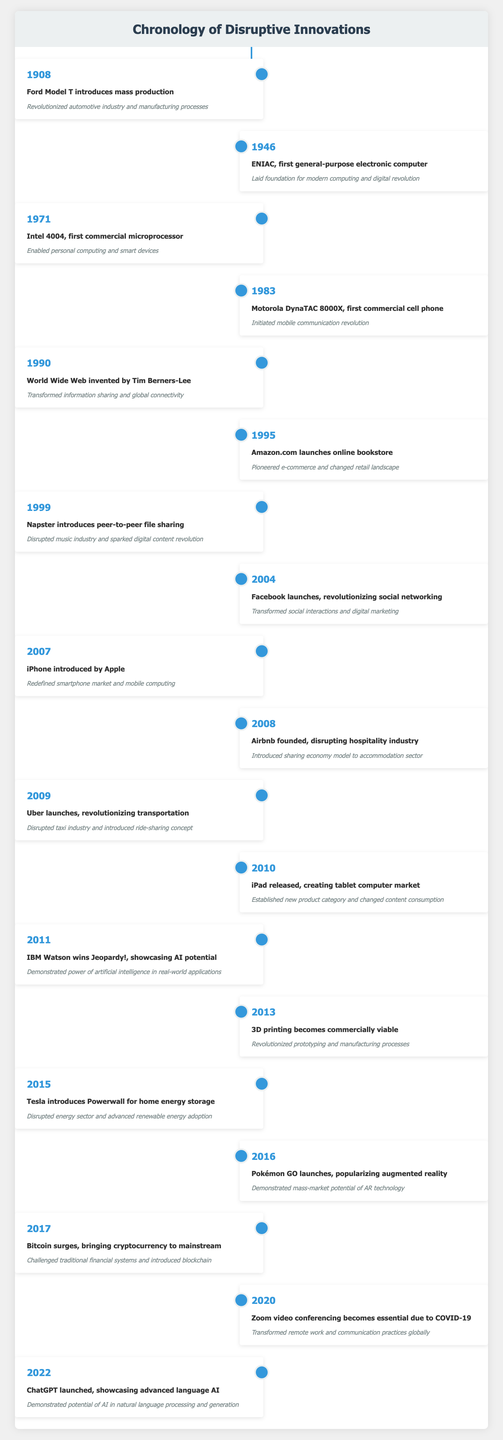What year was the first commercial cell phone introduced? The table states that the Motorola DynaTAC 8000X, which is the first commercial cell phone, was introduced in 1983.
Answer: 1983 What impact did the iPhone introduced by Apple have on the market? According to the table, the impact of the iPhone was that it redefined the smartphone market and mobile computing.
Answer: Redefined smartphone market and mobile computing How many years passed between the introduction of the Ford Model T and the ENIAC? The Ford Model T was introduced in 1908 and the ENIAC in 1946. The difference between 1946 and 1908 is 38 years.
Answer: 38 Was the World Wide Web invented before or after the introduction of Amazon.com? The table shows that the World Wide Web was invented in 1990 and Amazon.com launched in 1995. Thus, the Web was invented before Amazon.com.
Answer: Before Which innovation is associated with the year 2017? The table lists Bitcoin surging in 2017, bringing cryptocurrency to the mainstream.
Answer: Bitcoin How many innovations were introduced before the year 2000? Counting the events listed in the table, the innovations before 2000 are Ford Model T (1908), ENIAC (1946), Intel 4004 (1971), Motorola DynaTAC 8000X (1983), World Wide Web (1990), Amazon.com (1995), and Napster (1999), totaling 7 innovations.
Answer: 7 Which two innovations led to major shifts in communication technology? The table highlights that the Motorola DynaTAC 8000X initiated a mobile communication revolution and the World Wide Web transformed information sharing.
Answer: Motorola DynaTAC 8000X and World Wide Web What is the earliest innovation listed in the table, and what was its impact? The earliest innovation in the timeline is the Ford Model T introduced in 1908, which revolutionized the automotive industry and manufacturing processes.
Answer: Ford Model T; revolutionized automotive industry and manufacturing processes What year did 3D printing become commercially viable, and what effect did it have? The table shows that 3D printing became commercially viable in 2013, which revolutionized prototyping and manufacturing processes.
Answer: 2013; revolutionized prototyping and manufacturing processes 